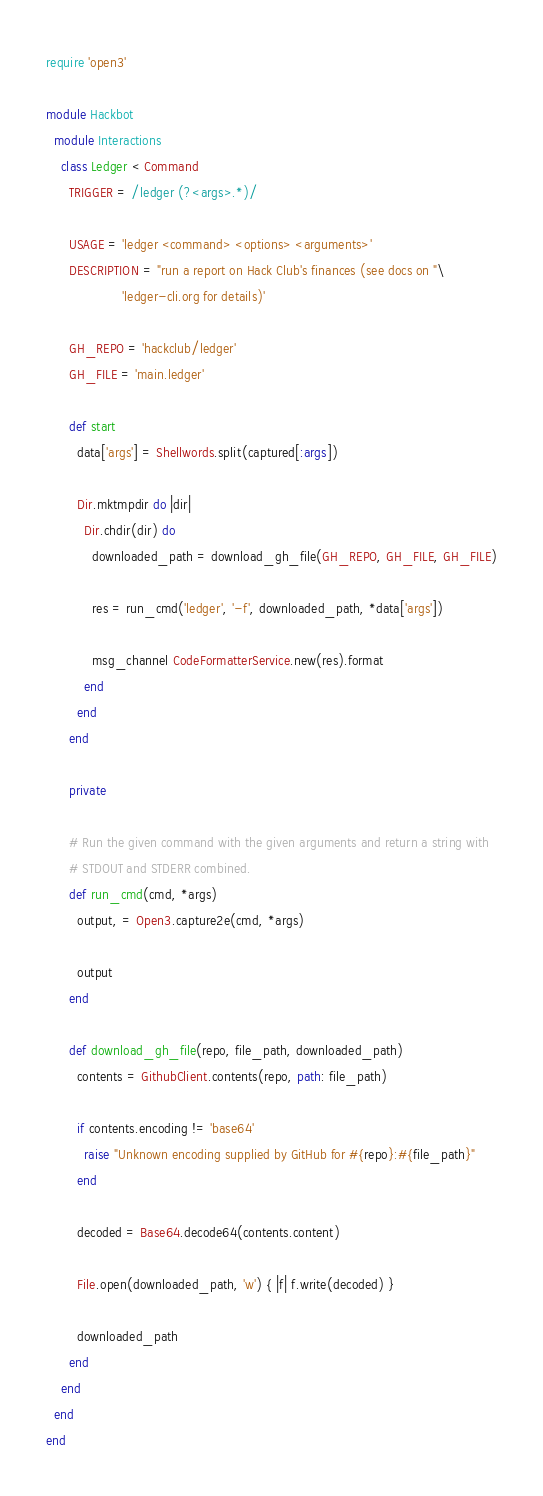Convert code to text. <code><loc_0><loc_0><loc_500><loc_500><_Ruby_>require 'open3'

module Hackbot
  module Interactions
    class Ledger < Command
      TRIGGER = /ledger (?<args>.*)/

      USAGE = 'ledger <command> <options> <arguments>'
      DESCRIPTION = "run a report on Hack Club's finances (see docs on "\
                    'ledger-cli.org for details)'

      GH_REPO = 'hackclub/ledger'
      GH_FILE = 'main.ledger'

      def start
        data['args'] = Shellwords.split(captured[:args])

        Dir.mktmpdir do |dir|
          Dir.chdir(dir) do
            downloaded_path = download_gh_file(GH_REPO, GH_FILE, GH_FILE)

            res = run_cmd('ledger', '-f', downloaded_path, *data['args'])

            msg_channel CodeFormatterService.new(res).format
          end
        end
      end

      private

      # Run the given command with the given arguments and return a string with
      # STDOUT and STDERR combined.
      def run_cmd(cmd, *args)
        output, = Open3.capture2e(cmd, *args)

        output
      end

      def download_gh_file(repo, file_path, downloaded_path)
        contents = GithubClient.contents(repo, path: file_path)

        if contents.encoding != 'base64'
          raise "Unknown encoding supplied by GitHub for #{repo}:#{file_path}"
        end

        decoded = Base64.decode64(contents.content)

        File.open(downloaded_path, 'w') { |f| f.write(decoded) }

        downloaded_path
      end
    end
  end
end
</code> 